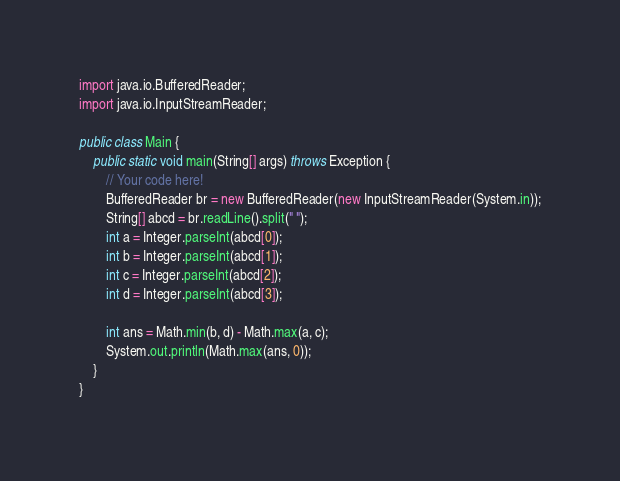<code> <loc_0><loc_0><loc_500><loc_500><_Java_>import java.io.BufferedReader;
import java.io.InputStreamReader;

public class Main {
    public static void main(String[] args) throws Exception {
        // Your code here!
        BufferedReader br = new BufferedReader(new InputStreamReader(System.in));
        String[] abcd = br.readLine().split(" ");
        int a = Integer.parseInt(abcd[0]);
        int b = Integer.parseInt(abcd[1]);
        int c = Integer.parseInt(abcd[2]);
        int d = Integer.parseInt(abcd[3]);
        
        int ans = Math.min(b, d) - Math.max(a, c);
        System.out.println(Math.max(ans, 0));
    }
}
</code> 